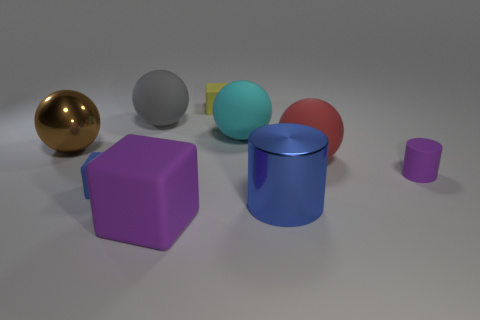How big is the blue object to the right of the tiny thing behind the purple rubber cylinder?
Offer a terse response. Large. There is a red ball that is the same material as the tiny blue cube; what size is it?
Make the answer very short. Large. What shape is the tiny matte object that is both on the left side of the cyan rubber thing and in front of the tiny yellow object?
Provide a succinct answer. Cube. Is the number of big blue cylinders that are behind the big brown metal thing the same as the number of red cylinders?
Offer a very short reply. Yes. How many objects are big gray cylinders or rubber cubes on the right side of the large rubber cube?
Offer a terse response. 1. Is there a blue rubber object of the same shape as the yellow thing?
Ensure brevity in your answer.  Yes. Is the number of big balls on the right side of the cyan rubber object the same as the number of big gray objects on the left side of the big brown shiny object?
Provide a short and direct response. No. What number of blue things are either large shiny objects or small matte cubes?
Keep it short and to the point. 2. How many purple cylinders are the same size as the red ball?
Your answer should be compact. 0. What is the color of the large object that is behind the brown metal thing and on the left side of the large purple matte thing?
Your answer should be very brief. Gray. 